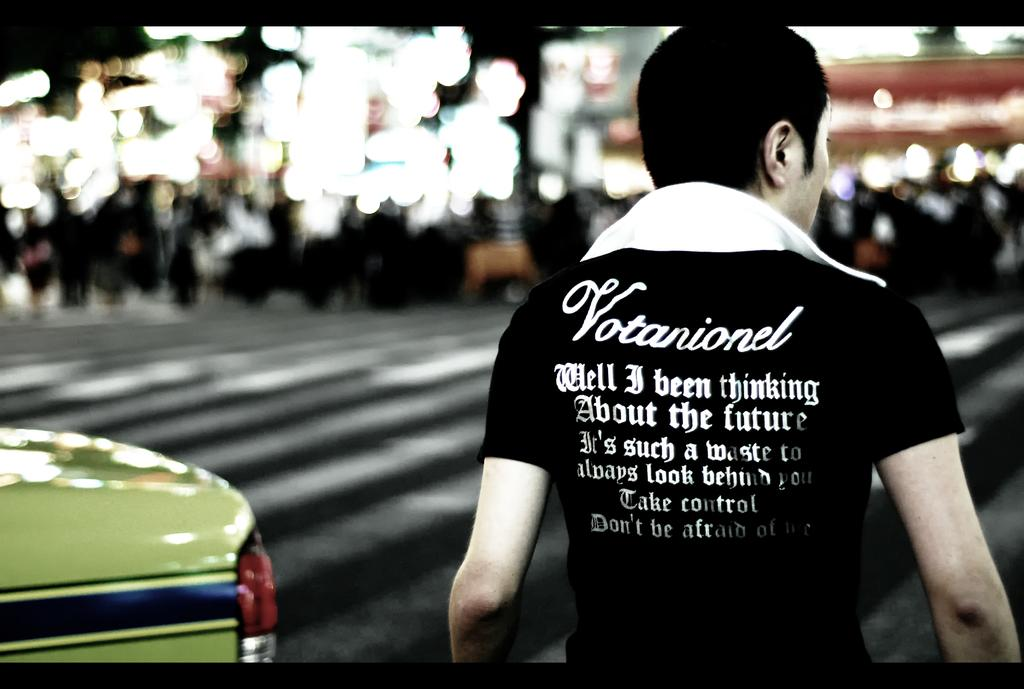Who is present in the image? There is a man in the image. Where is the man located in the image? The man is on the right side of the image. What is the man wearing in the image? The man is wearing a black t-shirt. What type of rock is the man sitting on in the image? There is no rock present in the image, and the man is not sitting down. 